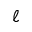Convert formula to latex. <formula><loc_0><loc_0><loc_500><loc_500>\ell</formula> 